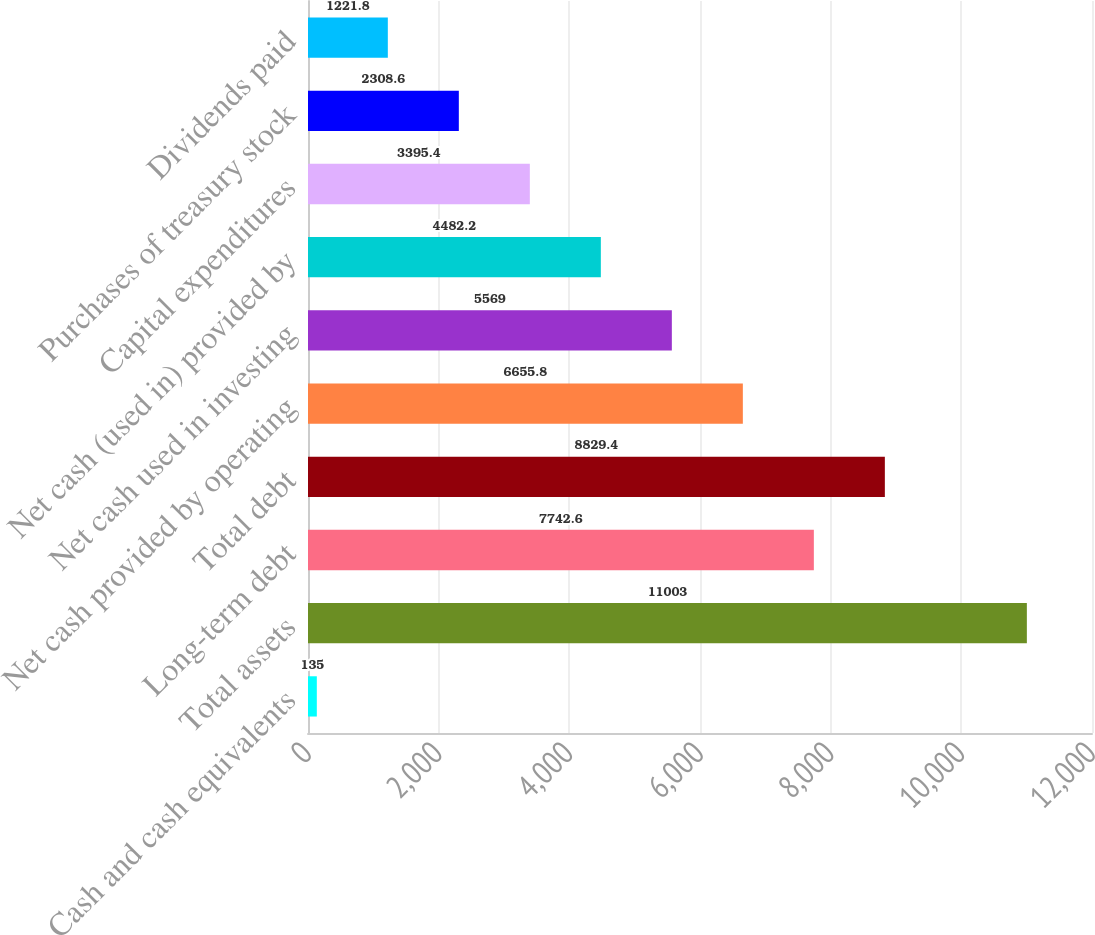<chart> <loc_0><loc_0><loc_500><loc_500><bar_chart><fcel>Cash and cash equivalents<fcel>Total assets<fcel>Long-term debt<fcel>Total debt<fcel>Net cash provided by operating<fcel>Net cash used in investing<fcel>Net cash (used in) provided by<fcel>Capital expenditures<fcel>Purchases of treasury stock<fcel>Dividends paid<nl><fcel>135<fcel>11003<fcel>7742.6<fcel>8829.4<fcel>6655.8<fcel>5569<fcel>4482.2<fcel>3395.4<fcel>2308.6<fcel>1221.8<nl></chart> 